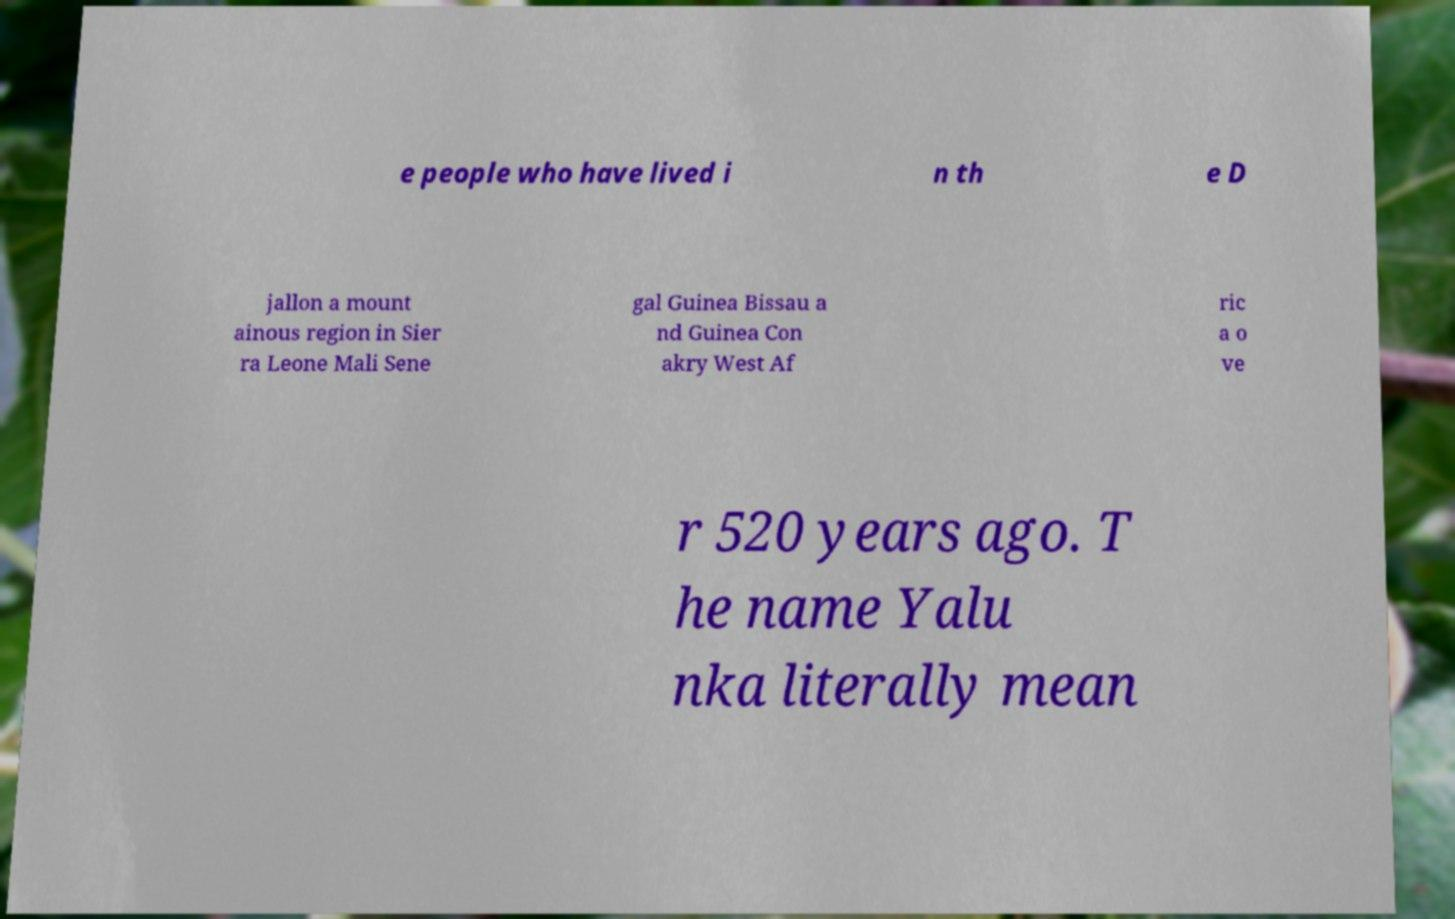Can you read and provide the text displayed in the image?This photo seems to have some interesting text. Can you extract and type it out for me? e people who have lived i n th e D jallon a mount ainous region in Sier ra Leone Mali Sene gal Guinea Bissau a nd Guinea Con akry West Af ric a o ve r 520 years ago. T he name Yalu nka literally mean 